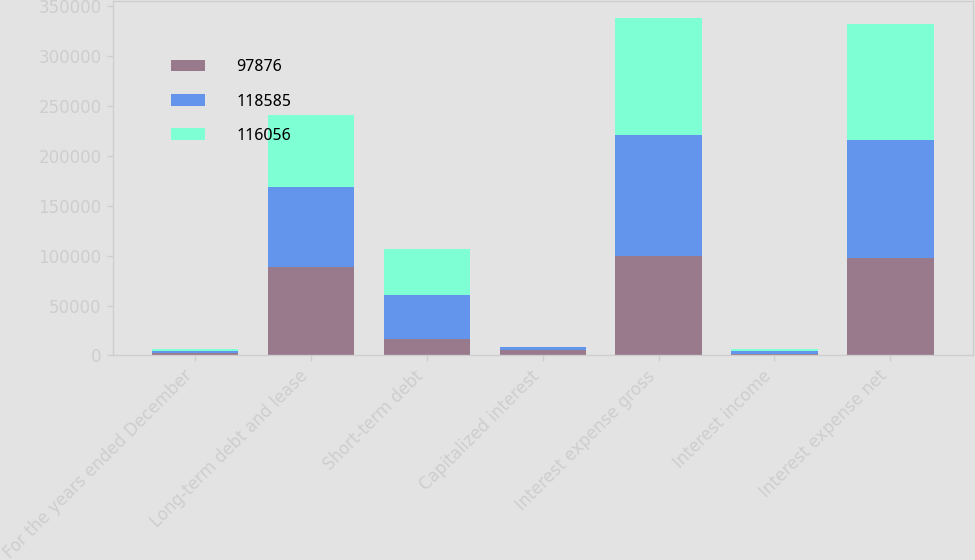Convert chart to OTSL. <chart><loc_0><loc_0><loc_500><loc_500><stacked_bar_chart><ecel><fcel>For the years ended December<fcel>Long-term debt and lease<fcel>Short-term debt<fcel>Capitalized interest<fcel>Interest expense gross<fcel>Interest income<fcel>Interest expense net<nl><fcel>97876<fcel>2008<fcel>88726<fcel>16731<fcel>5779<fcel>99678<fcel>1802<fcel>97876<nl><fcel>118585<fcel>2007<fcel>80351<fcel>43485<fcel>2770<fcel>121066<fcel>2481<fcel>118585<nl><fcel>116056<fcel>2006<fcel>71546<fcel>46269<fcel>77<fcel>117738<fcel>1682<fcel>116056<nl></chart> 